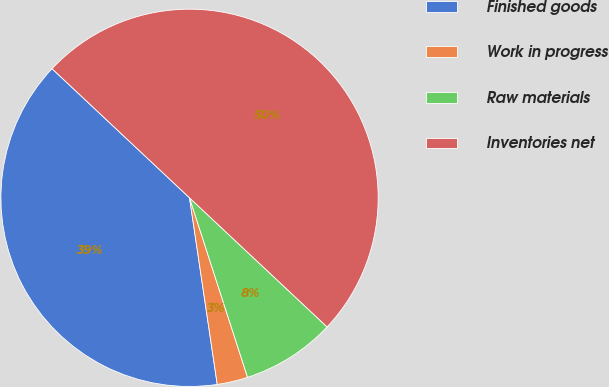Convert chart. <chart><loc_0><loc_0><loc_500><loc_500><pie_chart><fcel>Finished goods<fcel>Work in progress<fcel>Raw materials<fcel>Inventories net<nl><fcel>39.35%<fcel>2.63%<fcel>8.03%<fcel>50.0%<nl></chart> 